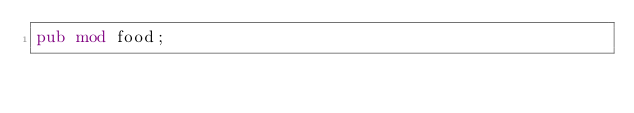Convert code to text. <code><loc_0><loc_0><loc_500><loc_500><_Rust_>pub mod food;
</code> 